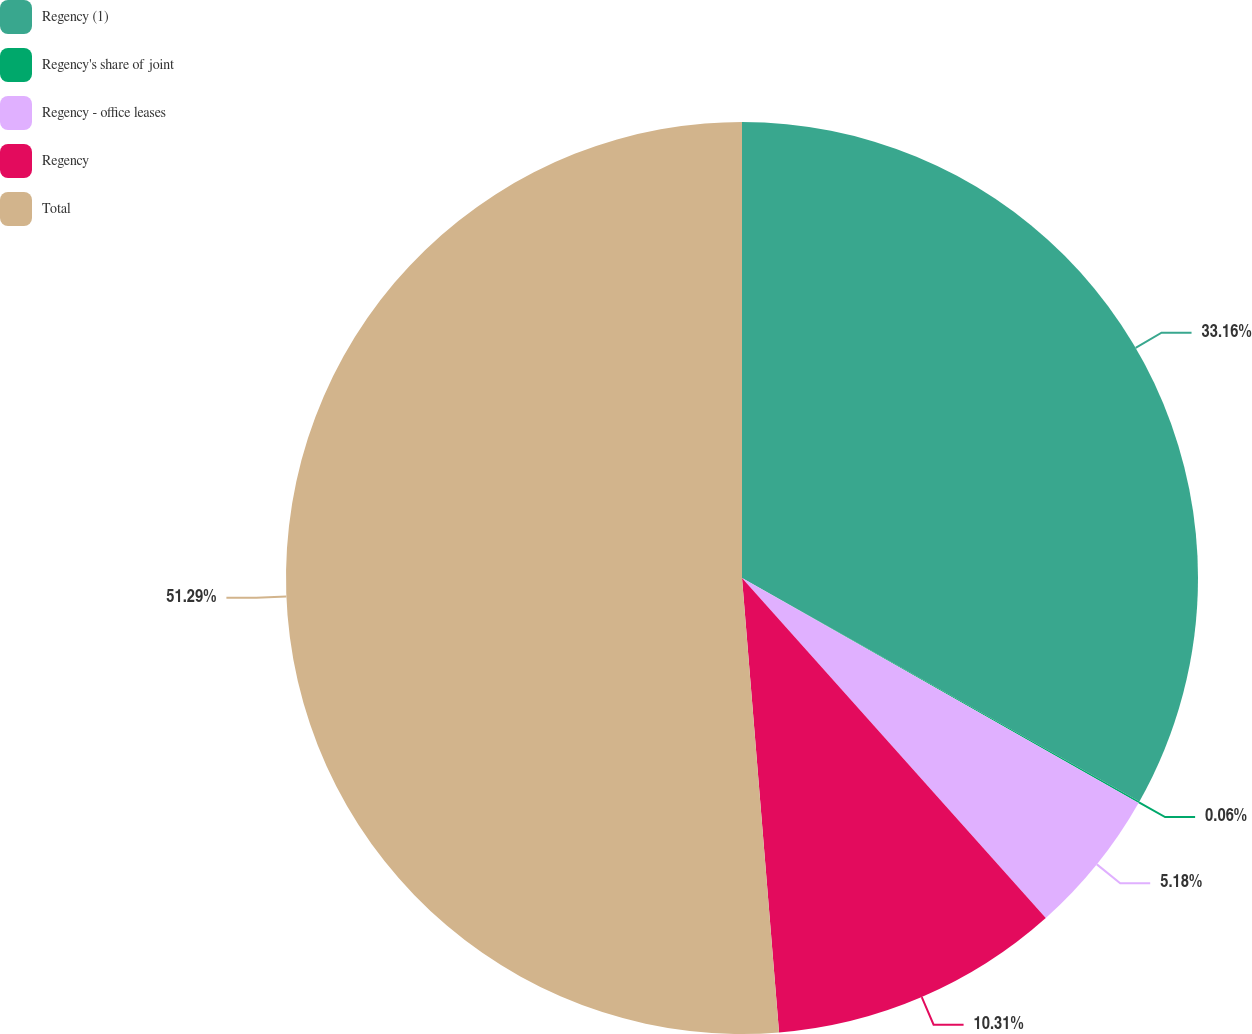<chart> <loc_0><loc_0><loc_500><loc_500><pie_chart><fcel>Regency (1)<fcel>Regency's share of joint<fcel>Regency - office leases<fcel>Regency<fcel>Total<nl><fcel>33.16%<fcel>0.06%<fcel>5.18%<fcel>10.31%<fcel>51.3%<nl></chart> 